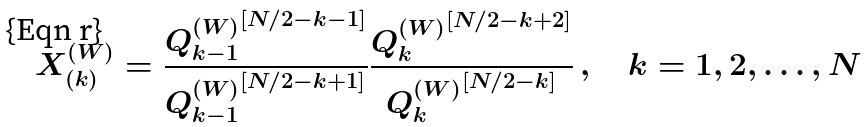<formula> <loc_0><loc_0><loc_500><loc_500>X ^ { ( W ) } _ { ( k ) } = \frac { { Q ^ { ( W ) } _ { k - 1 } } ^ { [ N / 2 - k - 1 ] } } { { Q ^ { ( W ) } _ { k - 1 } } ^ { [ N / 2 - k + 1 ] } } \frac { { Q ^ { ( W ) } _ { k } } ^ { [ N / 2 - k + 2 ] } } { { Q ^ { ( W ) } _ { k } } ^ { [ N / 2 - k ] } } \, , \quad k = 1 , 2 , \dots , N</formula> 